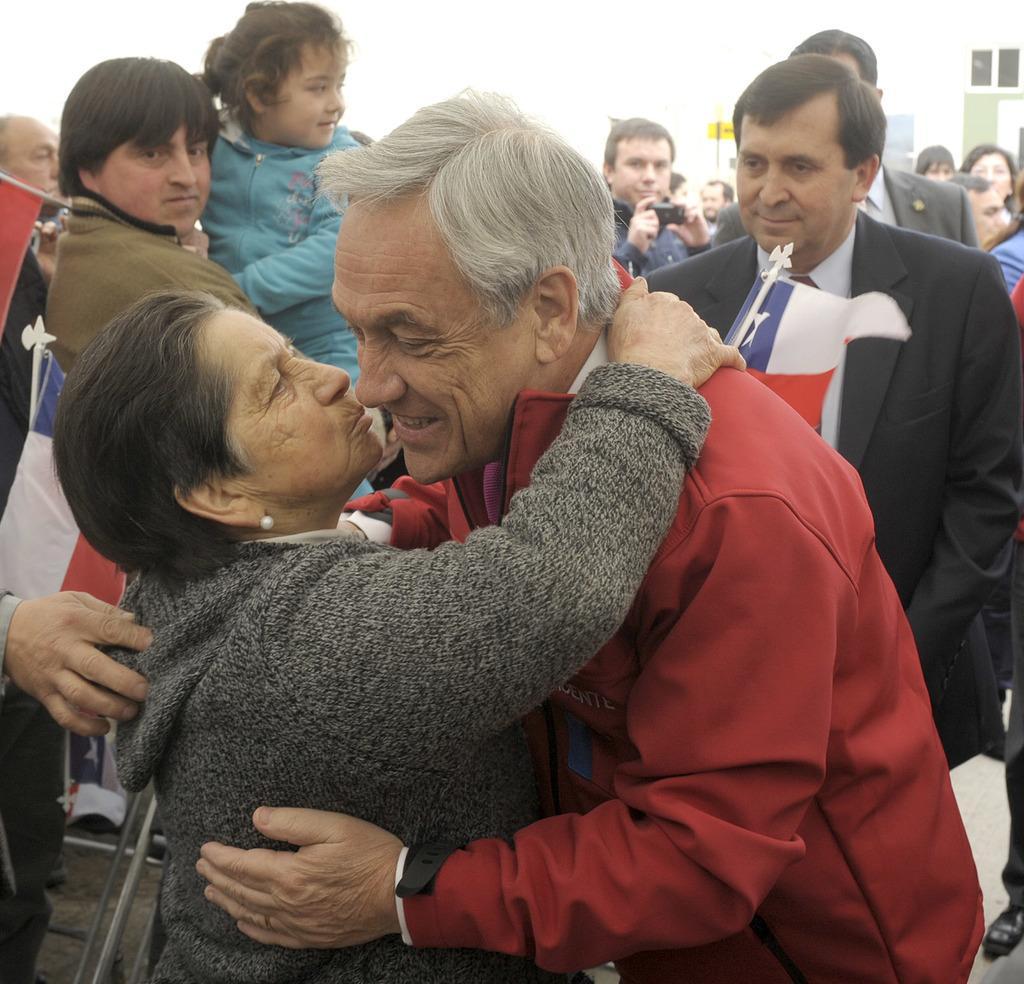Describe this image in one or two sentences. In this picture I can see two persons standing and hugging each other, and in the background there are flags and there are group of people standing. 